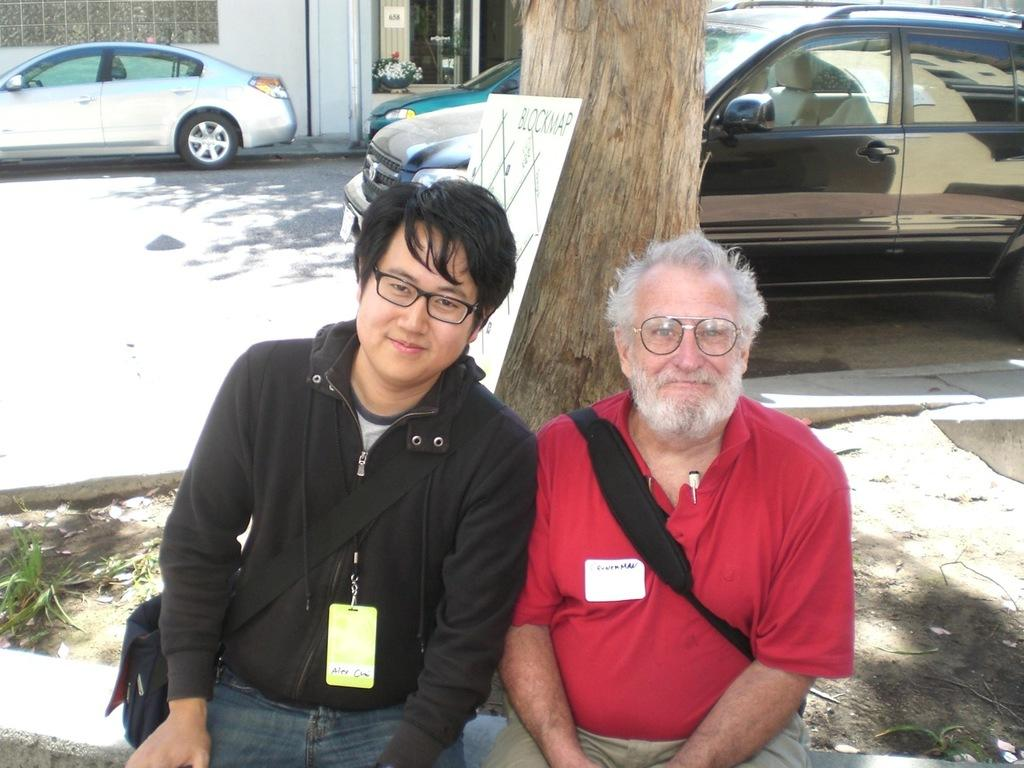What are the persons in the image doing? The persons in the image are sitting at a tree in the center of the image. What can be seen in the background of the image? There are vehicles, a road, and a building in the background of the image. What type of coil is being used to start a fire in the image? There is no coil or fire present in the image; it features persons sitting at a tree and vehicles, a road, and a building in the background. 